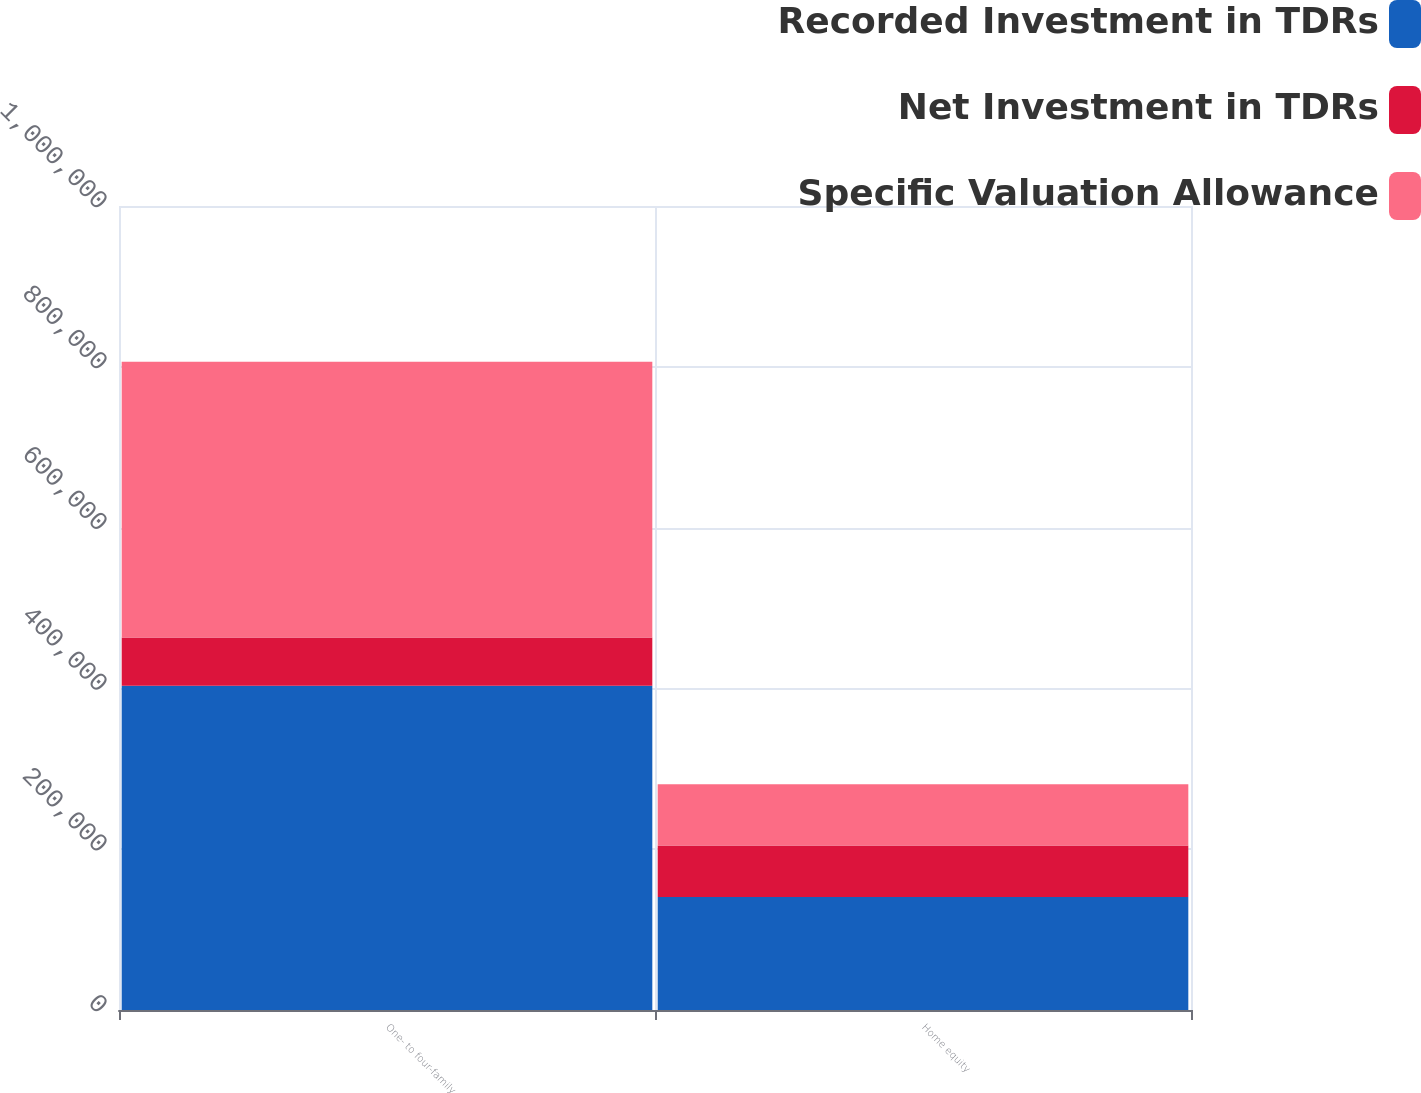Convert chart. <chart><loc_0><loc_0><loc_500><loc_500><stacked_bar_chart><ecel><fcel>One- to four-family<fcel>Home equity<nl><fcel>Recorded Investment in TDRs<fcel>403217<fcel>140410<nl><fcel>Net Investment in TDRs<fcel>60246<fcel>64128<nl><fcel>Specific Valuation Allowance<fcel>342971<fcel>76282<nl></chart> 